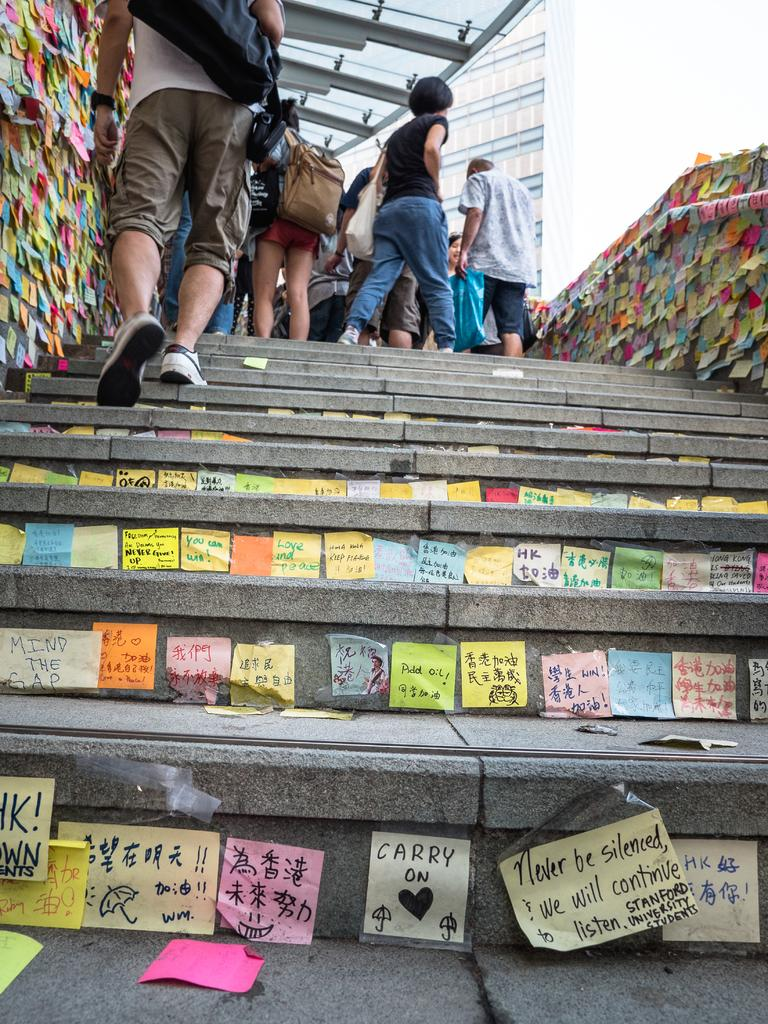<image>
Relay a brief, clear account of the picture shown. Stairs with a bunch of sticky post-it notes of all colors and one at bottom says carry on. 